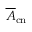<formula> <loc_0><loc_0><loc_500><loc_500>\overline { A } _ { c n }</formula> 